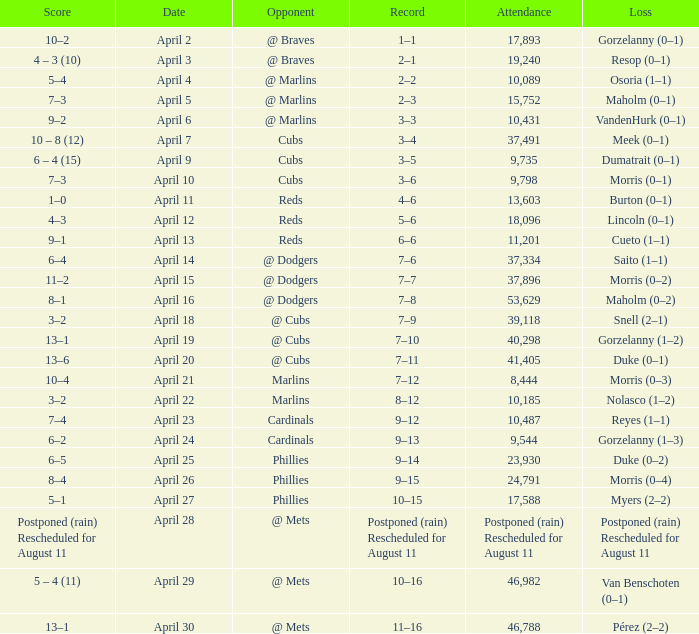What opponent had an attendance of 10,089? @ Marlins. 